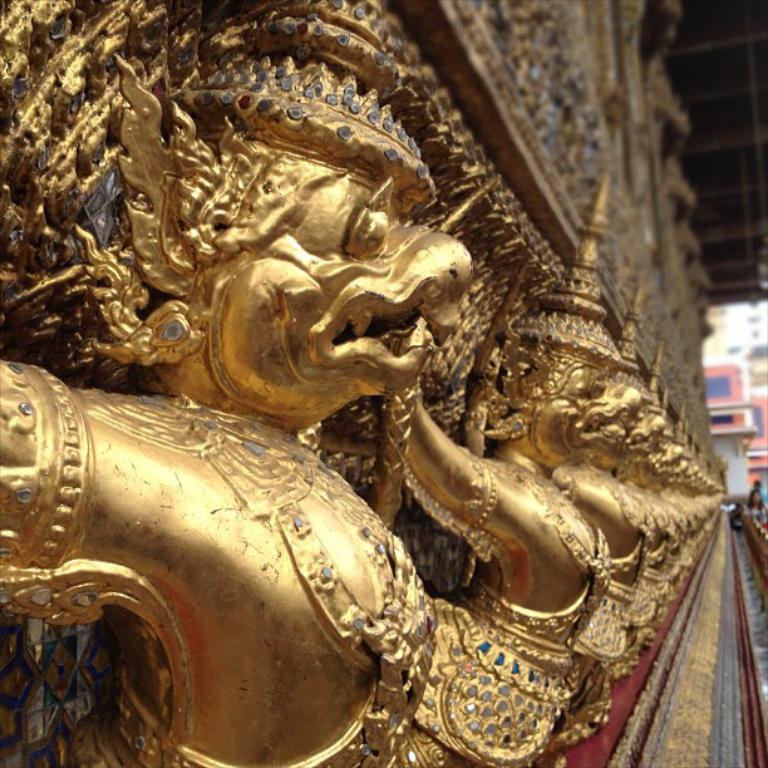What type of artwork can be seen in the image? There are sculptures in the image. What can be seen beneath the sculptures? The ground is visible in the image. Is there a person present in the image? Yes, there is a person in the image. What is visible above the sculptures? The roof is visible in the image. What type of honey can be tasted from the sculptures in the image? There is no honey present in the image, and the sculptures are not edible. 